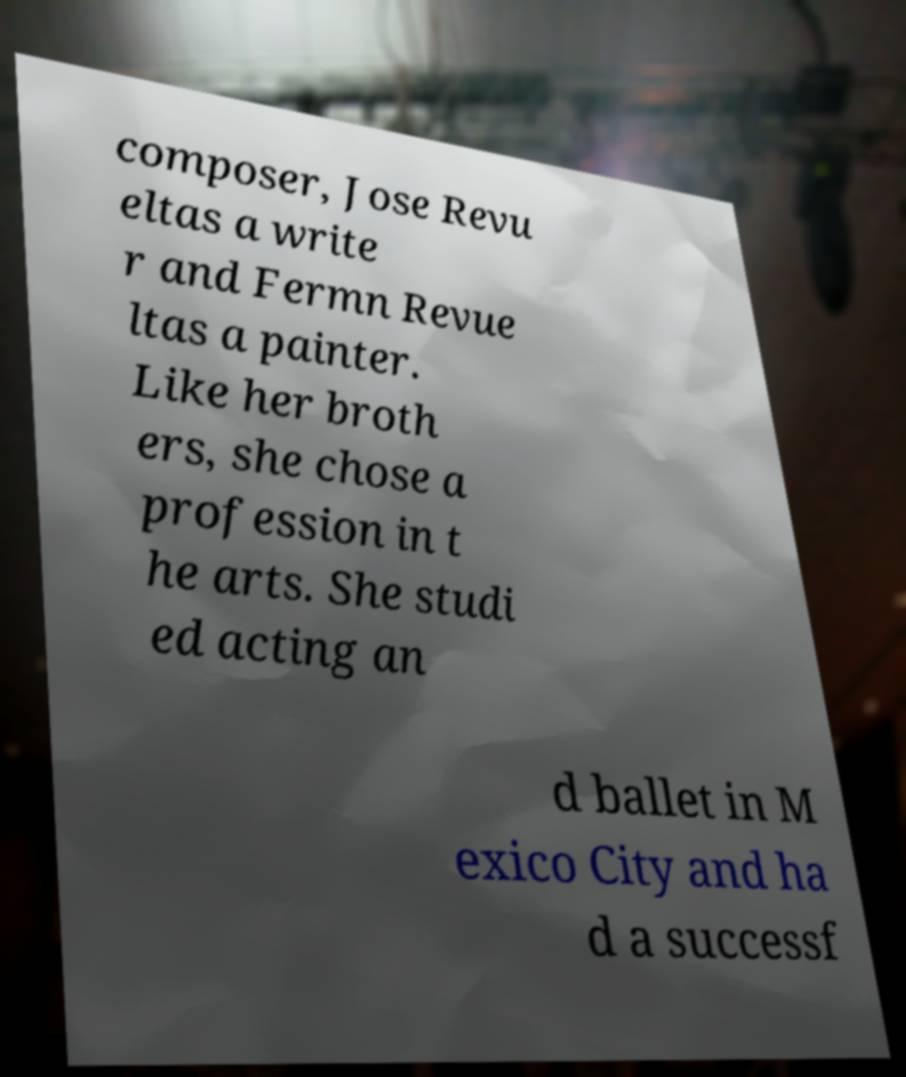There's text embedded in this image that I need extracted. Can you transcribe it verbatim? composer, Jose Revu eltas a write r and Fermn Revue ltas a painter. Like her broth ers, she chose a profession in t he arts. She studi ed acting an d ballet in M exico City and ha d a successf 